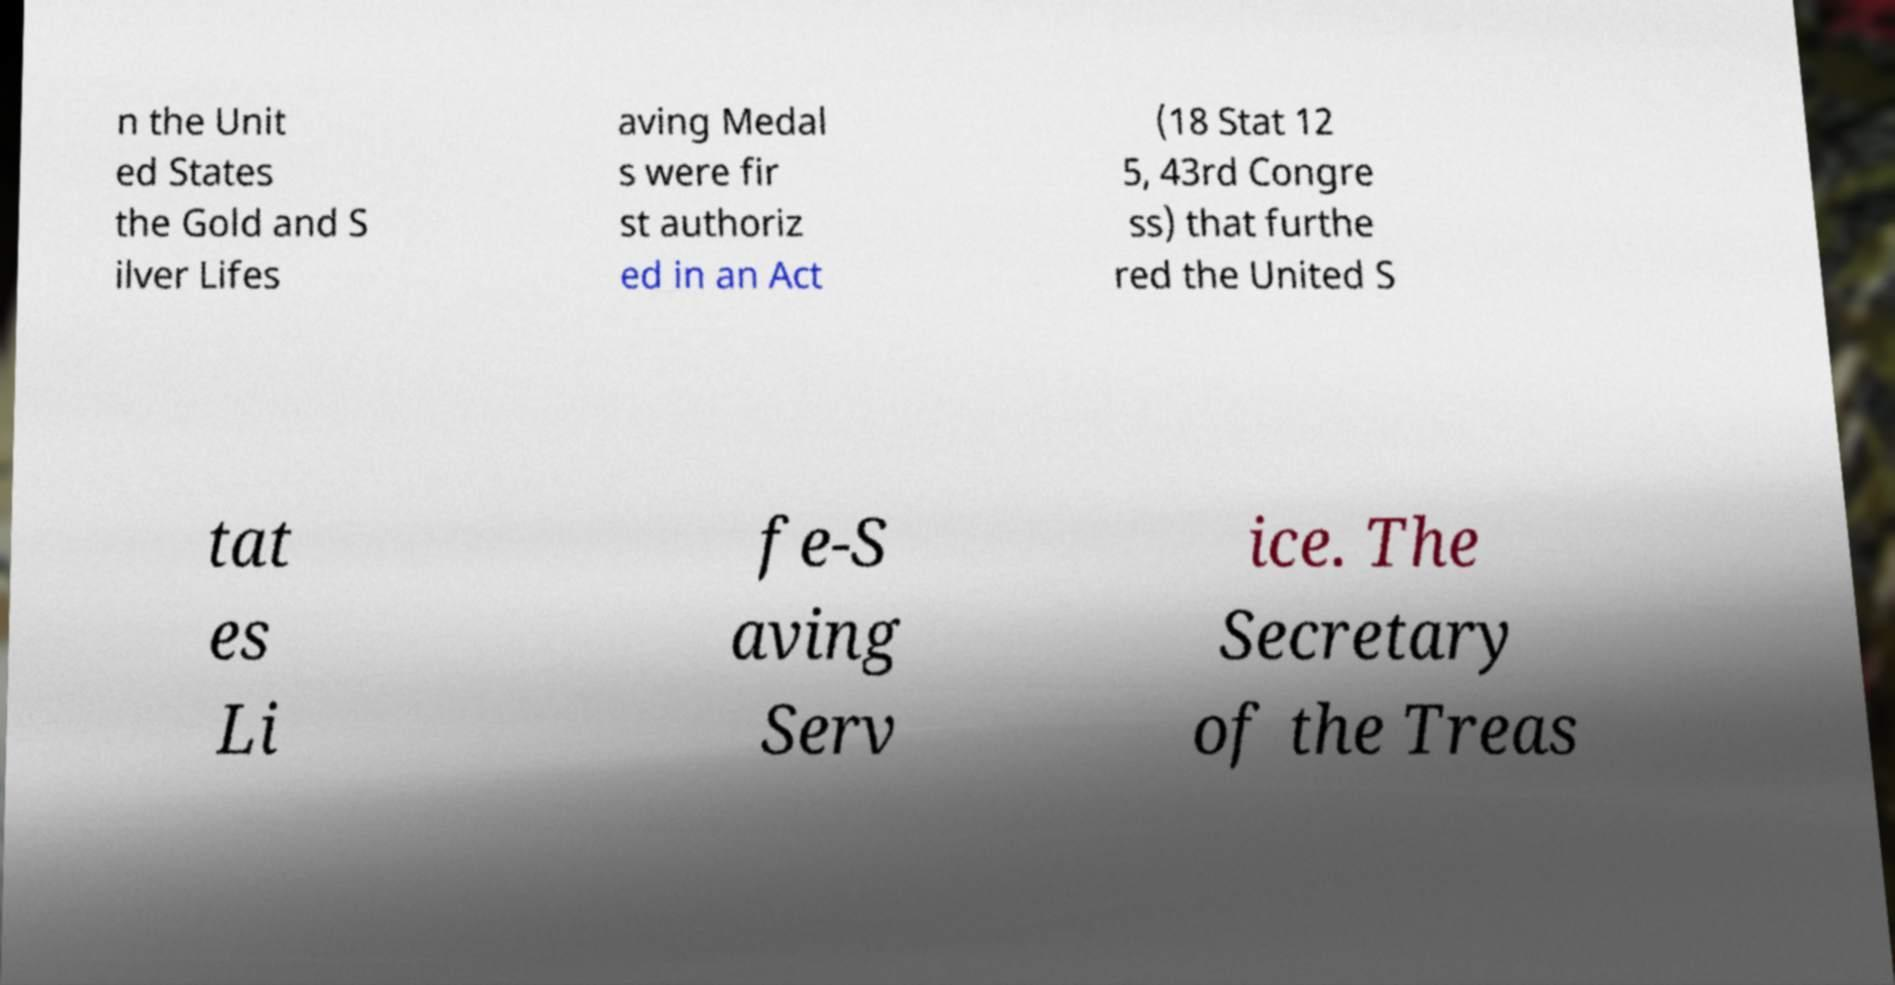What messages or text are displayed in this image? I need them in a readable, typed format. n the Unit ed States the Gold and S ilver Lifes aving Medal s were fir st authoriz ed in an Act (18 Stat 12 5, 43rd Congre ss) that furthe red the United S tat es Li fe-S aving Serv ice. The Secretary of the Treas 